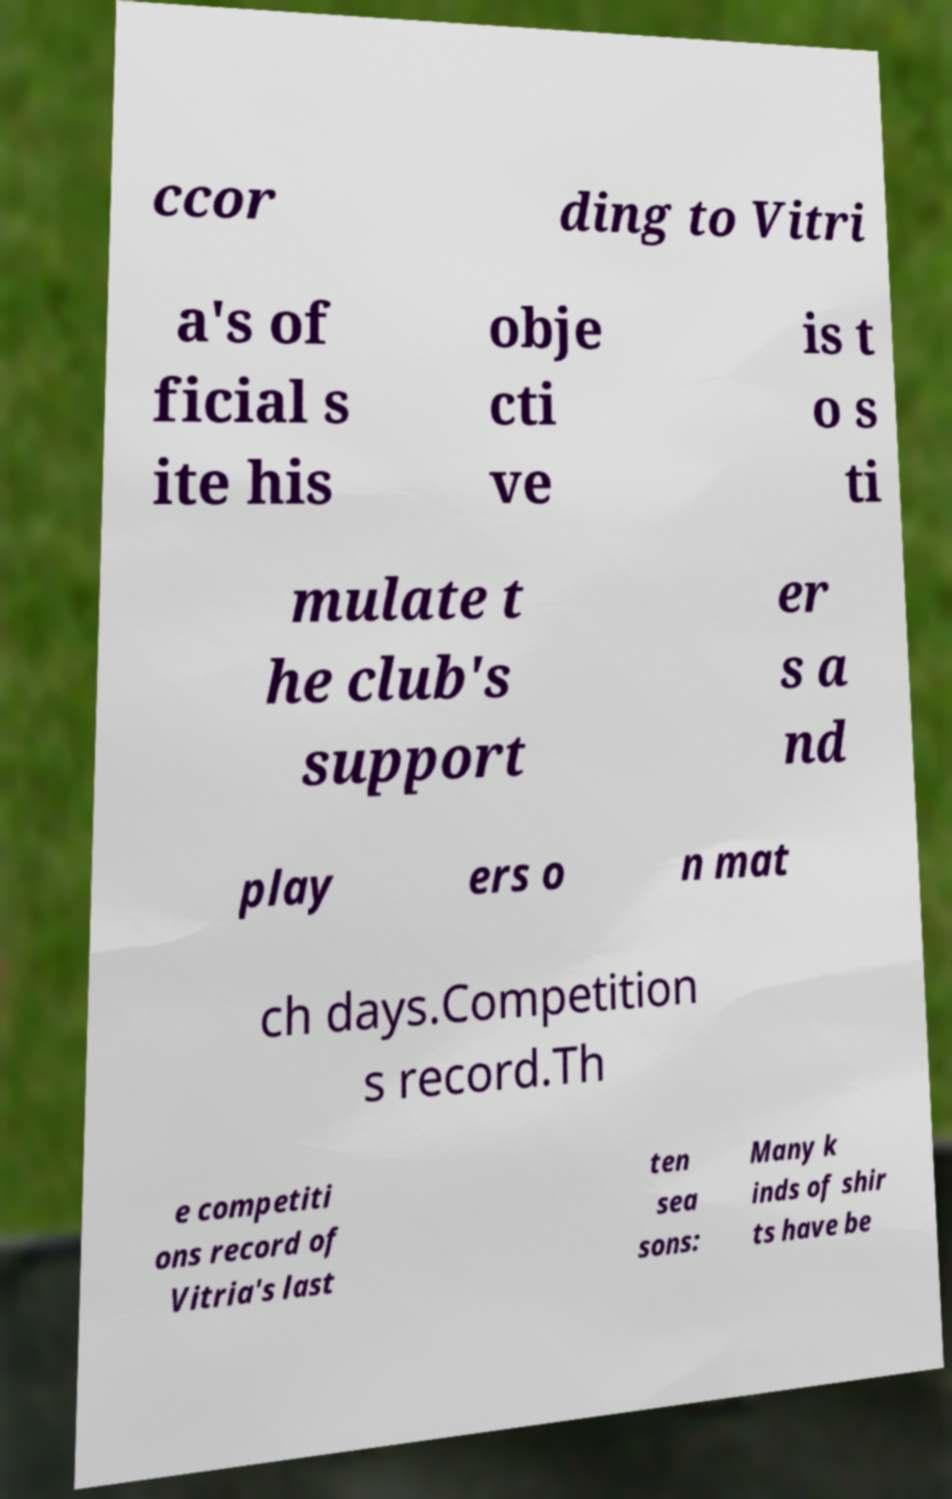I need the written content from this picture converted into text. Can you do that? ccor ding to Vitri a's of ficial s ite his obje cti ve is t o s ti mulate t he club's support er s a nd play ers o n mat ch days.Competition s record.Th e competiti ons record of Vitria's last ten sea sons: Many k inds of shir ts have be 